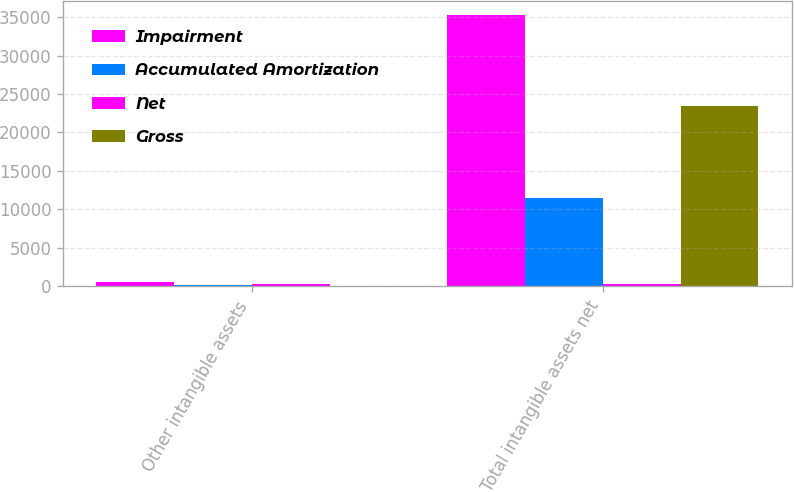Convert chart to OTSL. <chart><loc_0><loc_0><loc_500><loc_500><stacked_bar_chart><ecel><fcel>Other intangible assets<fcel>Total intangible assets net<nl><fcel>Impairment<fcel>500<fcel>35287<nl><fcel>Accumulated Amortization<fcel>148<fcel>11522<nl><fcel>Net<fcel>291<fcel>291<nl><fcel>Gross<fcel>61<fcel>23474<nl></chart> 